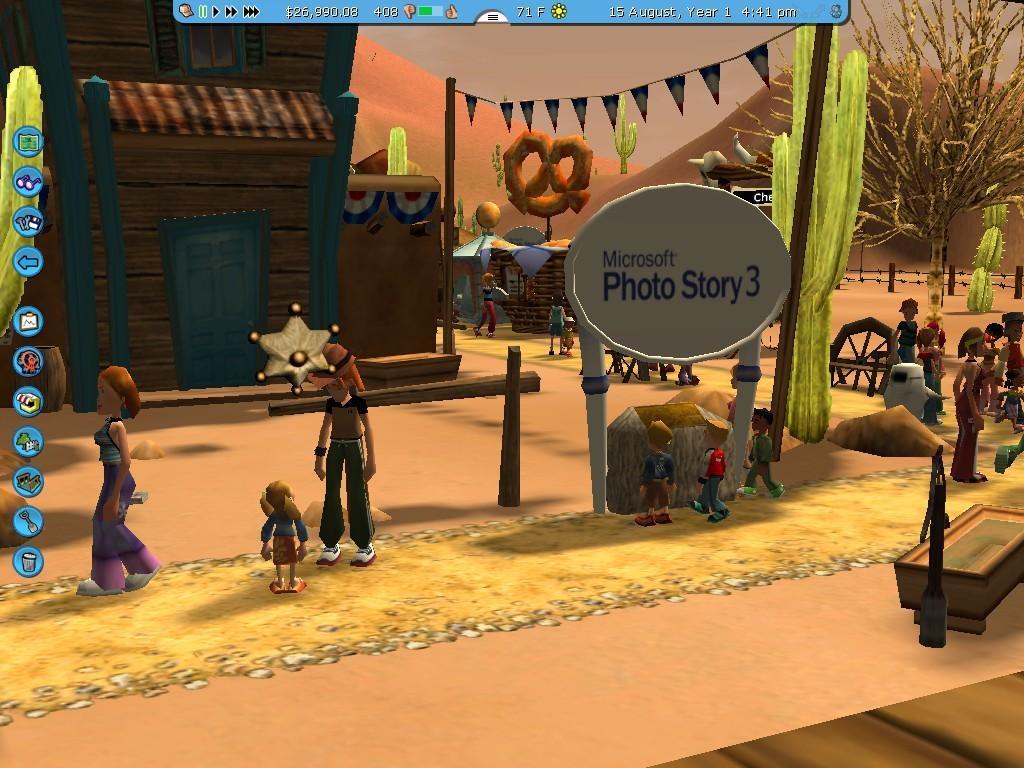Describe this image in one or two sentences. This is an animated image where we can see the animation of people, trees, houses, boards, a few more objects, hills and the wire fence in the background. 